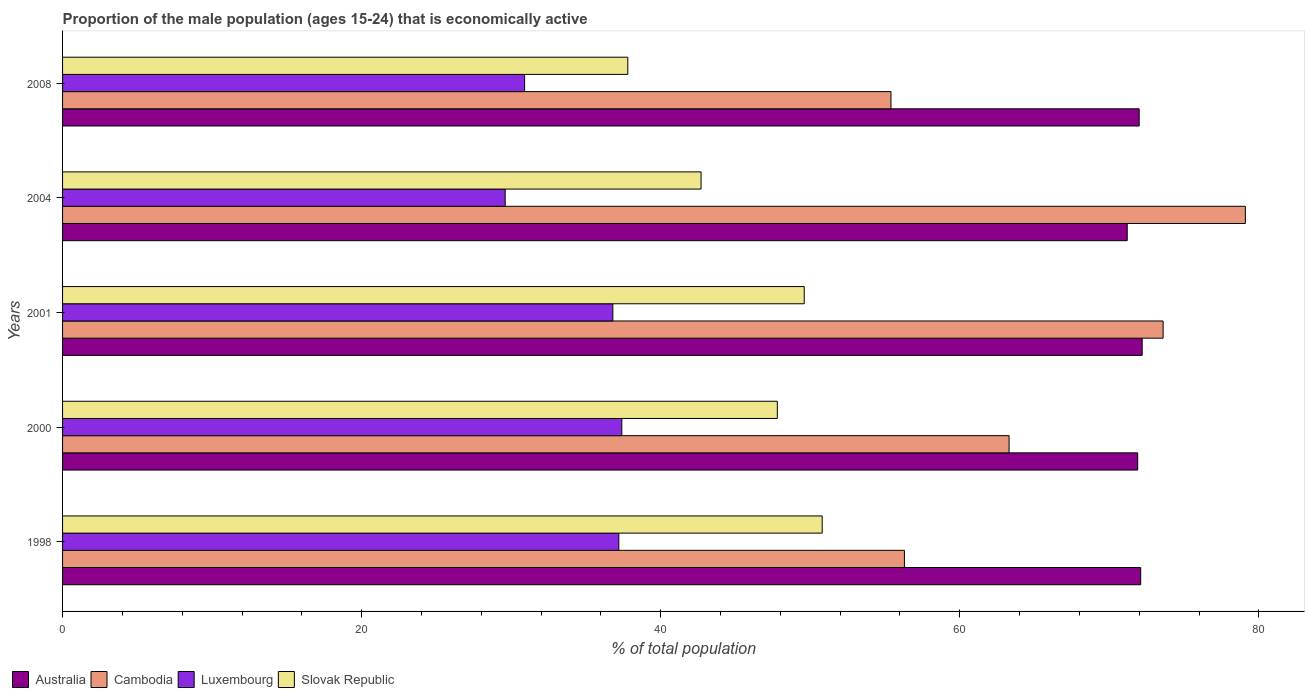Are the number of bars per tick equal to the number of legend labels?
Offer a terse response. Yes. How many bars are there on the 2nd tick from the bottom?
Your response must be concise. 4. In how many cases, is the number of bars for a given year not equal to the number of legend labels?
Ensure brevity in your answer.  0. What is the proportion of the male population that is economically active in Cambodia in 2000?
Provide a succinct answer. 63.3. Across all years, what is the maximum proportion of the male population that is economically active in Luxembourg?
Provide a succinct answer. 37.4. Across all years, what is the minimum proportion of the male population that is economically active in Luxembourg?
Give a very brief answer. 29.6. In which year was the proportion of the male population that is economically active in Slovak Republic maximum?
Provide a succinct answer. 1998. What is the total proportion of the male population that is economically active in Cambodia in the graph?
Provide a short and direct response. 327.7. What is the difference between the proportion of the male population that is economically active in Luxembourg in 1998 and that in 2004?
Provide a succinct answer. 7.6. What is the difference between the proportion of the male population that is economically active in Australia in 1998 and the proportion of the male population that is economically active in Cambodia in 2001?
Offer a terse response. -1.5. What is the average proportion of the male population that is economically active in Cambodia per year?
Ensure brevity in your answer.  65.54. In the year 2000, what is the difference between the proportion of the male population that is economically active in Australia and proportion of the male population that is economically active in Luxembourg?
Keep it short and to the point. 34.5. In how many years, is the proportion of the male population that is economically active in Cambodia greater than 4 %?
Ensure brevity in your answer.  5. What is the ratio of the proportion of the male population that is economically active in Australia in 1998 to that in 2001?
Keep it short and to the point. 1. Is the proportion of the male population that is economically active in Slovak Republic in 1998 less than that in 2004?
Provide a succinct answer. No. Is the difference between the proportion of the male population that is economically active in Australia in 2004 and 2008 greater than the difference between the proportion of the male population that is economically active in Luxembourg in 2004 and 2008?
Provide a short and direct response. Yes. What is the difference between the highest and the second highest proportion of the male population that is economically active in Australia?
Your answer should be very brief. 0.1. What is the difference between the highest and the lowest proportion of the male population that is economically active in Cambodia?
Offer a terse response. 23.7. In how many years, is the proportion of the male population that is economically active in Australia greater than the average proportion of the male population that is economically active in Australia taken over all years?
Offer a terse response. 4. What does the 4th bar from the top in 2008 represents?
Your answer should be compact. Australia. What does the 2nd bar from the bottom in 2008 represents?
Provide a short and direct response. Cambodia. Is it the case that in every year, the sum of the proportion of the male population that is economically active in Slovak Republic and proportion of the male population that is economically active in Luxembourg is greater than the proportion of the male population that is economically active in Australia?
Give a very brief answer. No. How many years are there in the graph?
Your response must be concise. 5. Are the values on the major ticks of X-axis written in scientific E-notation?
Offer a very short reply. No. Does the graph contain grids?
Provide a succinct answer. No. What is the title of the graph?
Make the answer very short. Proportion of the male population (ages 15-24) that is economically active. Does "Mozambique" appear as one of the legend labels in the graph?
Offer a very short reply. No. What is the label or title of the X-axis?
Your answer should be very brief. % of total population. What is the label or title of the Y-axis?
Provide a succinct answer. Years. What is the % of total population in Australia in 1998?
Your answer should be compact. 72.1. What is the % of total population in Cambodia in 1998?
Give a very brief answer. 56.3. What is the % of total population of Luxembourg in 1998?
Offer a terse response. 37.2. What is the % of total population in Slovak Republic in 1998?
Keep it short and to the point. 50.8. What is the % of total population of Australia in 2000?
Offer a very short reply. 71.9. What is the % of total population in Cambodia in 2000?
Offer a terse response. 63.3. What is the % of total population of Luxembourg in 2000?
Offer a very short reply. 37.4. What is the % of total population in Slovak Republic in 2000?
Provide a succinct answer. 47.8. What is the % of total population in Australia in 2001?
Offer a very short reply. 72.2. What is the % of total population of Cambodia in 2001?
Ensure brevity in your answer.  73.6. What is the % of total population of Luxembourg in 2001?
Give a very brief answer. 36.8. What is the % of total population of Slovak Republic in 2001?
Keep it short and to the point. 49.6. What is the % of total population in Australia in 2004?
Provide a short and direct response. 71.2. What is the % of total population in Cambodia in 2004?
Provide a short and direct response. 79.1. What is the % of total population of Luxembourg in 2004?
Keep it short and to the point. 29.6. What is the % of total population in Slovak Republic in 2004?
Ensure brevity in your answer.  42.7. What is the % of total population of Australia in 2008?
Your response must be concise. 72. What is the % of total population in Cambodia in 2008?
Offer a terse response. 55.4. What is the % of total population of Luxembourg in 2008?
Give a very brief answer. 30.9. What is the % of total population in Slovak Republic in 2008?
Your answer should be compact. 37.8. Across all years, what is the maximum % of total population of Australia?
Make the answer very short. 72.2. Across all years, what is the maximum % of total population in Cambodia?
Give a very brief answer. 79.1. Across all years, what is the maximum % of total population in Luxembourg?
Your answer should be compact. 37.4. Across all years, what is the maximum % of total population in Slovak Republic?
Give a very brief answer. 50.8. Across all years, what is the minimum % of total population of Australia?
Make the answer very short. 71.2. Across all years, what is the minimum % of total population of Cambodia?
Ensure brevity in your answer.  55.4. Across all years, what is the minimum % of total population of Luxembourg?
Make the answer very short. 29.6. Across all years, what is the minimum % of total population in Slovak Republic?
Your response must be concise. 37.8. What is the total % of total population in Australia in the graph?
Make the answer very short. 359.4. What is the total % of total population in Cambodia in the graph?
Your answer should be compact. 327.7. What is the total % of total population in Luxembourg in the graph?
Provide a succinct answer. 171.9. What is the total % of total population of Slovak Republic in the graph?
Provide a short and direct response. 228.7. What is the difference between the % of total population of Luxembourg in 1998 and that in 2000?
Your answer should be very brief. -0.2. What is the difference between the % of total population of Slovak Republic in 1998 and that in 2000?
Your response must be concise. 3. What is the difference between the % of total population in Cambodia in 1998 and that in 2001?
Keep it short and to the point. -17.3. What is the difference between the % of total population of Luxembourg in 1998 and that in 2001?
Give a very brief answer. 0.4. What is the difference between the % of total population in Slovak Republic in 1998 and that in 2001?
Provide a succinct answer. 1.2. What is the difference between the % of total population in Australia in 1998 and that in 2004?
Make the answer very short. 0.9. What is the difference between the % of total population in Cambodia in 1998 and that in 2004?
Offer a very short reply. -22.8. What is the difference between the % of total population of Luxembourg in 1998 and that in 2004?
Provide a short and direct response. 7.6. What is the difference between the % of total population of Australia in 1998 and that in 2008?
Offer a terse response. 0.1. What is the difference between the % of total population of Cambodia in 1998 and that in 2008?
Provide a short and direct response. 0.9. What is the difference between the % of total population of Luxembourg in 1998 and that in 2008?
Ensure brevity in your answer.  6.3. What is the difference between the % of total population in Slovak Republic in 1998 and that in 2008?
Provide a short and direct response. 13. What is the difference between the % of total population of Slovak Republic in 2000 and that in 2001?
Keep it short and to the point. -1.8. What is the difference between the % of total population of Cambodia in 2000 and that in 2004?
Give a very brief answer. -15.8. What is the difference between the % of total population of Luxembourg in 2000 and that in 2004?
Make the answer very short. 7.8. What is the difference between the % of total population in Slovak Republic in 2000 and that in 2004?
Provide a succinct answer. 5.1. What is the difference between the % of total population of Australia in 2000 and that in 2008?
Provide a short and direct response. -0.1. What is the difference between the % of total population in Cambodia in 2000 and that in 2008?
Offer a terse response. 7.9. What is the difference between the % of total population in Luxembourg in 2000 and that in 2008?
Provide a succinct answer. 6.5. What is the difference between the % of total population of Slovak Republic in 2000 and that in 2008?
Give a very brief answer. 10. What is the difference between the % of total population in Australia in 2001 and that in 2004?
Keep it short and to the point. 1. What is the difference between the % of total population in Cambodia in 2001 and that in 2004?
Make the answer very short. -5.5. What is the difference between the % of total population of Luxembourg in 2001 and that in 2004?
Your answer should be very brief. 7.2. What is the difference between the % of total population in Australia in 2001 and that in 2008?
Ensure brevity in your answer.  0.2. What is the difference between the % of total population in Cambodia in 2001 and that in 2008?
Your answer should be very brief. 18.2. What is the difference between the % of total population of Luxembourg in 2001 and that in 2008?
Your answer should be compact. 5.9. What is the difference between the % of total population of Slovak Republic in 2001 and that in 2008?
Ensure brevity in your answer.  11.8. What is the difference between the % of total population in Australia in 2004 and that in 2008?
Provide a succinct answer. -0.8. What is the difference between the % of total population of Cambodia in 2004 and that in 2008?
Keep it short and to the point. 23.7. What is the difference between the % of total population in Luxembourg in 2004 and that in 2008?
Offer a very short reply. -1.3. What is the difference between the % of total population in Slovak Republic in 2004 and that in 2008?
Your response must be concise. 4.9. What is the difference between the % of total population in Australia in 1998 and the % of total population in Cambodia in 2000?
Ensure brevity in your answer.  8.8. What is the difference between the % of total population of Australia in 1998 and the % of total population of Luxembourg in 2000?
Ensure brevity in your answer.  34.7. What is the difference between the % of total population of Australia in 1998 and the % of total population of Slovak Republic in 2000?
Ensure brevity in your answer.  24.3. What is the difference between the % of total population of Cambodia in 1998 and the % of total population of Luxembourg in 2000?
Your answer should be very brief. 18.9. What is the difference between the % of total population of Cambodia in 1998 and the % of total population of Slovak Republic in 2000?
Your answer should be very brief. 8.5. What is the difference between the % of total population of Luxembourg in 1998 and the % of total population of Slovak Republic in 2000?
Keep it short and to the point. -10.6. What is the difference between the % of total population in Australia in 1998 and the % of total population in Luxembourg in 2001?
Offer a terse response. 35.3. What is the difference between the % of total population in Australia in 1998 and the % of total population in Slovak Republic in 2001?
Keep it short and to the point. 22.5. What is the difference between the % of total population of Luxembourg in 1998 and the % of total population of Slovak Republic in 2001?
Offer a very short reply. -12.4. What is the difference between the % of total population of Australia in 1998 and the % of total population of Luxembourg in 2004?
Ensure brevity in your answer.  42.5. What is the difference between the % of total population of Australia in 1998 and the % of total population of Slovak Republic in 2004?
Provide a short and direct response. 29.4. What is the difference between the % of total population in Cambodia in 1998 and the % of total population in Luxembourg in 2004?
Offer a very short reply. 26.7. What is the difference between the % of total population of Australia in 1998 and the % of total population of Cambodia in 2008?
Provide a short and direct response. 16.7. What is the difference between the % of total population in Australia in 1998 and the % of total population in Luxembourg in 2008?
Offer a terse response. 41.2. What is the difference between the % of total population of Australia in 1998 and the % of total population of Slovak Republic in 2008?
Offer a terse response. 34.3. What is the difference between the % of total population of Cambodia in 1998 and the % of total population of Luxembourg in 2008?
Keep it short and to the point. 25.4. What is the difference between the % of total population of Cambodia in 1998 and the % of total population of Slovak Republic in 2008?
Ensure brevity in your answer.  18.5. What is the difference between the % of total population of Luxembourg in 1998 and the % of total population of Slovak Republic in 2008?
Offer a terse response. -0.6. What is the difference between the % of total population of Australia in 2000 and the % of total population of Cambodia in 2001?
Ensure brevity in your answer.  -1.7. What is the difference between the % of total population of Australia in 2000 and the % of total population of Luxembourg in 2001?
Your response must be concise. 35.1. What is the difference between the % of total population in Australia in 2000 and the % of total population in Slovak Republic in 2001?
Keep it short and to the point. 22.3. What is the difference between the % of total population of Cambodia in 2000 and the % of total population of Luxembourg in 2001?
Keep it short and to the point. 26.5. What is the difference between the % of total population of Cambodia in 2000 and the % of total population of Slovak Republic in 2001?
Your answer should be compact. 13.7. What is the difference between the % of total population of Luxembourg in 2000 and the % of total population of Slovak Republic in 2001?
Provide a short and direct response. -12.2. What is the difference between the % of total population in Australia in 2000 and the % of total population in Cambodia in 2004?
Offer a terse response. -7.2. What is the difference between the % of total population of Australia in 2000 and the % of total population of Luxembourg in 2004?
Offer a terse response. 42.3. What is the difference between the % of total population in Australia in 2000 and the % of total population in Slovak Republic in 2004?
Your response must be concise. 29.2. What is the difference between the % of total population in Cambodia in 2000 and the % of total population in Luxembourg in 2004?
Your answer should be very brief. 33.7. What is the difference between the % of total population of Cambodia in 2000 and the % of total population of Slovak Republic in 2004?
Provide a succinct answer. 20.6. What is the difference between the % of total population of Luxembourg in 2000 and the % of total population of Slovak Republic in 2004?
Your answer should be very brief. -5.3. What is the difference between the % of total population of Australia in 2000 and the % of total population of Cambodia in 2008?
Provide a short and direct response. 16.5. What is the difference between the % of total population of Australia in 2000 and the % of total population of Luxembourg in 2008?
Make the answer very short. 41. What is the difference between the % of total population of Australia in 2000 and the % of total population of Slovak Republic in 2008?
Keep it short and to the point. 34.1. What is the difference between the % of total population of Cambodia in 2000 and the % of total population of Luxembourg in 2008?
Your response must be concise. 32.4. What is the difference between the % of total population in Australia in 2001 and the % of total population in Cambodia in 2004?
Give a very brief answer. -6.9. What is the difference between the % of total population in Australia in 2001 and the % of total population in Luxembourg in 2004?
Offer a terse response. 42.6. What is the difference between the % of total population in Australia in 2001 and the % of total population in Slovak Republic in 2004?
Keep it short and to the point. 29.5. What is the difference between the % of total population of Cambodia in 2001 and the % of total population of Slovak Republic in 2004?
Give a very brief answer. 30.9. What is the difference between the % of total population in Luxembourg in 2001 and the % of total population in Slovak Republic in 2004?
Ensure brevity in your answer.  -5.9. What is the difference between the % of total population in Australia in 2001 and the % of total population in Luxembourg in 2008?
Provide a short and direct response. 41.3. What is the difference between the % of total population of Australia in 2001 and the % of total population of Slovak Republic in 2008?
Your answer should be compact. 34.4. What is the difference between the % of total population in Cambodia in 2001 and the % of total population in Luxembourg in 2008?
Keep it short and to the point. 42.7. What is the difference between the % of total population of Cambodia in 2001 and the % of total population of Slovak Republic in 2008?
Make the answer very short. 35.8. What is the difference between the % of total population in Luxembourg in 2001 and the % of total population in Slovak Republic in 2008?
Offer a terse response. -1. What is the difference between the % of total population in Australia in 2004 and the % of total population in Luxembourg in 2008?
Keep it short and to the point. 40.3. What is the difference between the % of total population of Australia in 2004 and the % of total population of Slovak Republic in 2008?
Keep it short and to the point. 33.4. What is the difference between the % of total population of Cambodia in 2004 and the % of total population of Luxembourg in 2008?
Offer a terse response. 48.2. What is the difference between the % of total population of Cambodia in 2004 and the % of total population of Slovak Republic in 2008?
Provide a succinct answer. 41.3. What is the difference between the % of total population of Luxembourg in 2004 and the % of total population of Slovak Republic in 2008?
Offer a terse response. -8.2. What is the average % of total population of Australia per year?
Provide a short and direct response. 71.88. What is the average % of total population in Cambodia per year?
Your answer should be compact. 65.54. What is the average % of total population of Luxembourg per year?
Provide a succinct answer. 34.38. What is the average % of total population in Slovak Republic per year?
Ensure brevity in your answer.  45.74. In the year 1998, what is the difference between the % of total population in Australia and % of total population in Cambodia?
Provide a short and direct response. 15.8. In the year 1998, what is the difference between the % of total population in Australia and % of total population in Luxembourg?
Your answer should be compact. 34.9. In the year 1998, what is the difference between the % of total population of Australia and % of total population of Slovak Republic?
Your answer should be very brief. 21.3. In the year 1998, what is the difference between the % of total population of Cambodia and % of total population of Luxembourg?
Your answer should be very brief. 19.1. In the year 1998, what is the difference between the % of total population in Luxembourg and % of total population in Slovak Republic?
Give a very brief answer. -13.6. In the year 2000, what is the difference between the % of total population of Australia and % of total population of Luxembourg?
Give a very brief answer. 34.5. In the year 2000, what is the difference between the % of total population of Australia and % of total population of Slovak Republic?
Ensure brevity in your answer.  24.1. In the year 2000, what is the difference between the % of total population of Cambodia and % of total population of Luxembourg?
Your answer should be compact. 25.9. In the year 2000, what is the difference between the % of total population in Cambodia and % of total population in Slovak Republic?
Offer a very short reply. 15.5. In the year 2001, what is the difference between the % of total population of Australia and % of total population of Luxembourg?
Your answer should be very brief. 35.4. In the year 2001, what is the difference between the % of total population of Australia and % of total population of Slovak Republic?
Offer a very short reply. 22.6. In the year 2001, what is the difference between the % of total population in Cambodia and % of total population in Luxembourg?
Make the answer very short. 36.8. In the year 2001, what is the difference between the % of total population of Luxembourg and % of total population of Slovak Republic?
Your response must be concise. -12.8. In the year 2004, what is the difference between the % of total population in Australia and % of total population in Luxembourg?
Give a very brief answer. 41.6. In the year 2004, what is the difference between the % of total population of Cambodia and % of total population of Luxembourg?
Give a very brief answer. 49.5. In the year 2004, what is the difference between the % of total population of Cambodia and % of total population of Slovak Republic?
Offer a very short reply. 36.4. In the year 2004, what is the difference between the % of total population in Luxembourg and % of total population in Slovak Republic?
Keep it short and to the point. -13.1. In the year 2008, what is the difference between the % of total population in Australia and % of total population in Cambodia?
Offer a very short reply. 16.6. In the year 2008, what is the difference between the % of total population of Australia and % of total population of Luxembourg?
Ensure brevity in your answer.  41.1. In the year 2008, what is the difference between the % of total population in Australia and % of total population in Slovak Republic?
Give a very brief answer. 34.2. In the year 2008, what is the difference between the % of total population of Cambodia and % of total population of Luxembourg?
Offer a terse response. 24.5. In the year 2008, what is the difference between the % of total population of Cambodia and % of total population of Slovak Republic?
Give a very brief answer. 17.6. What is the ratio of the % of total population of Australia in 1998 to that in 2000?
Offer a terse response. 1. What is the ratio of the % of total population of Cambodia in 1998 to that in 2000?
Your response must be concise. 0.89. What is the ratio of the % of total population in Slovak Republic in 1998 to that in 2000?
Ensure brevity in your answer.  1.06. What is the ratio of the % of total population in Cambodia in 1998 to that in 2001?
Your answer should be very brief. 0.76. What is the ratio of the % of total population in Luxembourg in 1998 to that in 2001?
Offer a very short reply. 1.01. What is the ratio of the % of total population of Slovak Republic in 1998 to that in 2001?
Keep it short and to the point. 1.02. What is the ratio of the % of total population of Australia in 1998 to that in 2004?
Provide a succinct answer. 1.01. What is the ratio of the % of total population of Cambodia in 1998 to that in 2004?
Keep it short and to the point. 0.71. What is the ratio of the % of total population of Luxembourg in 1998 to that in 2004?
Your answer should be very brief. 1.26. What is the ratio of the % of total population in Slovak Republic in 1998 to that in 2004?
Make the answer very short. 1.19. What is the ratio of the % of total population in Australia in 1998 to that in 2008?
Give a very brief answer. 1. What is the ratio of the % of total population of Cambodia in 1998 to that in 2008?
Your response must be concise. 1.02. What is the ratio of the % of total population in Luxembourg in 1998 to that in 2008?
Provide a succinct answer. 1.2. What is the ratio of the % of total population in Slovak Republic in 1998 to that in 2008?
Ensure brevity in your answer.  1.34. What is the ratio of the % of total population in Australia in 2000 to that in 2001?
Provide a short and direct response. 1. What is the ratio of the % of total population in Cambodia in 2000 to that in 2001?
Keep it short and to the point. 0.86. What is the ratio of the % of total population in Luxembourg in 2000 to that in 2001?
Make the answer very short. 1.02. What is the ratio of the % of total population of Slovak Republic in 2000 to that in 2001?
Provide a short and direct response. 0.96. What is the ratio of the % of total population of Australia in 2000 to that in 2004?
Give a very brief answer. 1.01. What is the ratio of the % of total population in Cambodia in 2000 to that in 2004?
Give a very brief answer. 0.8. What is the ratio of the % of total population of Luxembourg in 2000 to that in 2004?
Your answer should be compact. 1.26. What is the ratio of the % of total population of Slovak Republic in 2000 to that in 2004?
Your response must be concise. 1.12. What is the ratio of the % of total population in Australia in 2000 to that in 2008?
Your answer should be very brief. 1. What is the ratio of the % of total population in Cambodia in 2000 to that in 2008?
Provide a short and direct response. 1.14. What is the ratio of the % of total population in Luxembourg in 2000 to that in 2008?
Make the answer very short. 1.21. What is the ratio of the % of total population of Slovak Republic in 2000 to that in 2008?
Your answer should be very brief. 1.26. What is the ratio of the % of total population in Cambodia in 2001 to that in 2004?
Your answer should be very brief. 0.93. What is the ratio of the % of total population in Luxembourg in 2001 to that in 2004?
Give a very brief answer. 1.24. What is the ratio of the % of total population of Slovak Republic in 2001 to that in 2004?
Your response must be concise. 1.16. What is the ratio of the % of total population of Cambodia in 2001 to that in 2008?
Keep it short and to the point. 1.33. What is the ratio of the % of total population in Luxembourg in 2001 to that in 2008?
Your answer should be very brief. 1.19. What is the ratio of the % of total population in Slovak Republic in 2001 to that in 2008?
Give a very brief answer. 1.31. What is the ratio of the % of total population in Australia in 2004 to that in 2008?
Make the answer very short. 0.99. What is the ratio of the % of total population in Cambodia in 2004 to that in 2008?
Your answer should be compact. 1.43. What is the ratio of the % of total population in Luxembourg in 2004 to that in 2008?
Provide a short and direct response. 0.96. What is the ratio of the % of total population of Slovak Republic in 2004 to that in 2008?
Your answer should be compact. 1.13. What is the difference between the highest and the second highest % of total population of Australia?
Make the answer very short. 0.1. What is the difference between the highest and the second highest % of total population of Cambodia?
Offer a terse response. 5.5. What is the difference between the highest and the second highest % of total population of Slovak Republic?
Give a very brief answer. 1.2. What is the difference between the highest and the lowest % of total population of Cambodia?
Your response must be concise. 23.7. 